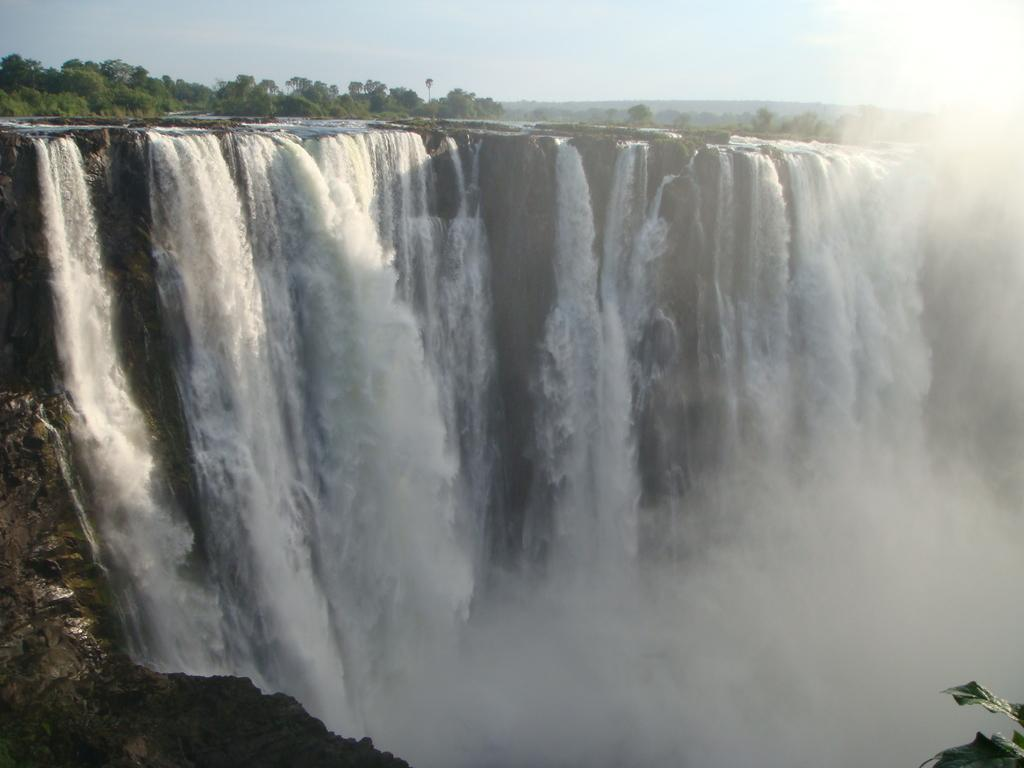What natural feature is the main subject of the image? There is a waterfall in the image. What type of vegetation can be seen in the background of the image? There are trees in the background of the image. What else is visible in the background of the image? The sky is visible in the background of the image. What color is the crayon used to draw the waterfall in the image? There is no crayon present in the image; it is a photograph or illustration of a waterfall. What discovery was made at the location of the waterfall in the image? The image does not provide information about any discoveries made at the location of the waterfall. 